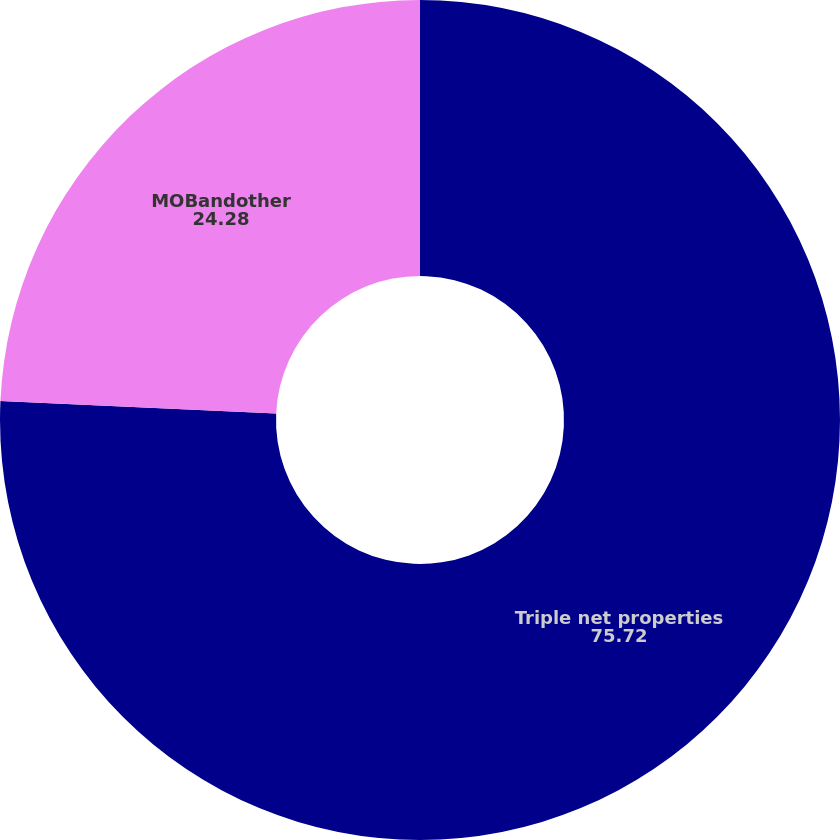<chart> <loc_0><loc_0><loc_500><loc_500><pie_chart><fcel>Triple net properties<fcel>MOBandother<nl><fcel>75.72%<fcel>24.28%<nl></chart> 